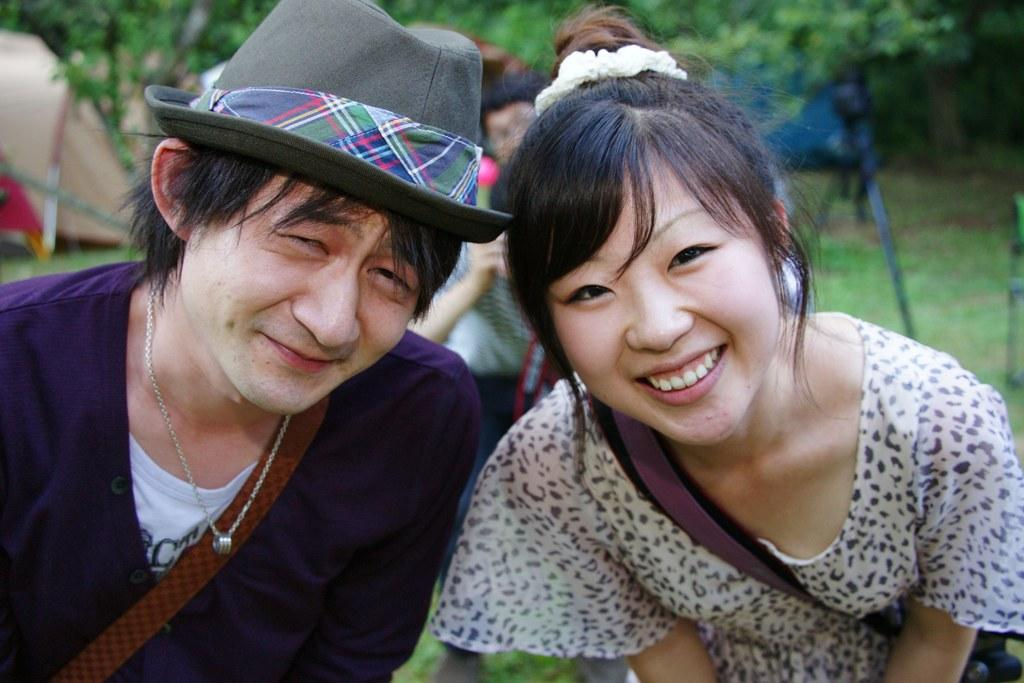How many people are in the image? There are two people in the image, a man and a woman. What are the people in the image doing? Both the man and the woman are standing and smiling. Who is holding an object in the image? There is a person holding an object in the image, but it is not specified which person. What can be seen in the background of the image? There are leaves and other objects in the background of the image. Can you tell me how many attractions are visible in the image? There is no mention of attractions in the image, so it is not possible to determine how many attractions are visible. Is there a river flowing in the background of the image? There is no river visible in the background of the image; it features leaves and other objects. 